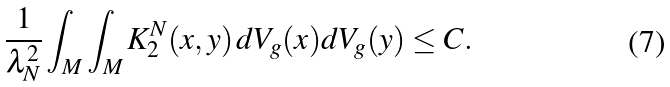Convert formula to latex. <formula><loc_0><loc_0><loc_500><loc_500>\frac { 1 } { \lambda _ { N } ^ { 2 } } \int _ { M } \int _ { M } K ^ { N } _ { 2 } ( x , y ) \, d V _ { g } ( x ) d V _ { g } ( y ) \leq C .</formula> 